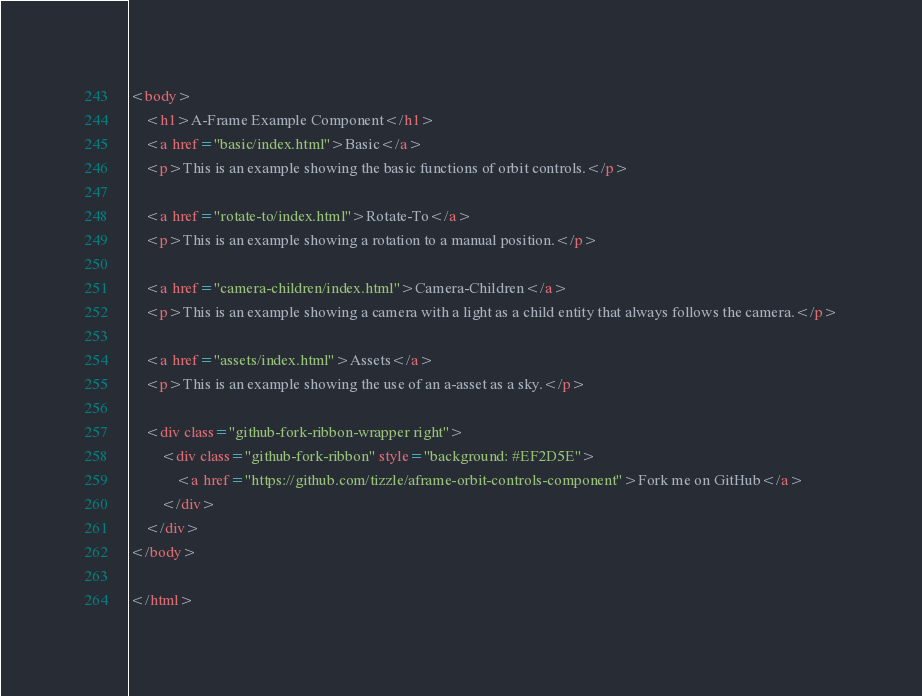Convert code to text. <code><loc_0><loc_0><loc_500><loc_500><_HTML_><body>
    <h1>A-Frame Example Component</h1>
    <a href="basic/index.html">Basic</a>
    <p>This is an example showing the basic functions of orbit controls.</p>

    <a href="rotate-to/index.html">Rotate-To</a>
    <p>This is an example showing a rotation to a manual position.</p>

    <a href="camera-children/index.html">Camera-Children</a>
    <p>This is an example showing a camera with a light as a child entity that always follows the camera.</p>

    <a href="assets/index.html">Assets</a>
    <p>This is an example showing the use of an a-asset as a sky.</p>

    <div class="github-fork-ribbon-wrapper right">
        <div class="github-fork-ribbon" style="background: #EF2D5E">
            <a href="https://github.com/tizzle/aframe-orbit-controls-component">Fork me on GitHub</a>
        </div>
    </div>
</body>

</html>
</code> 